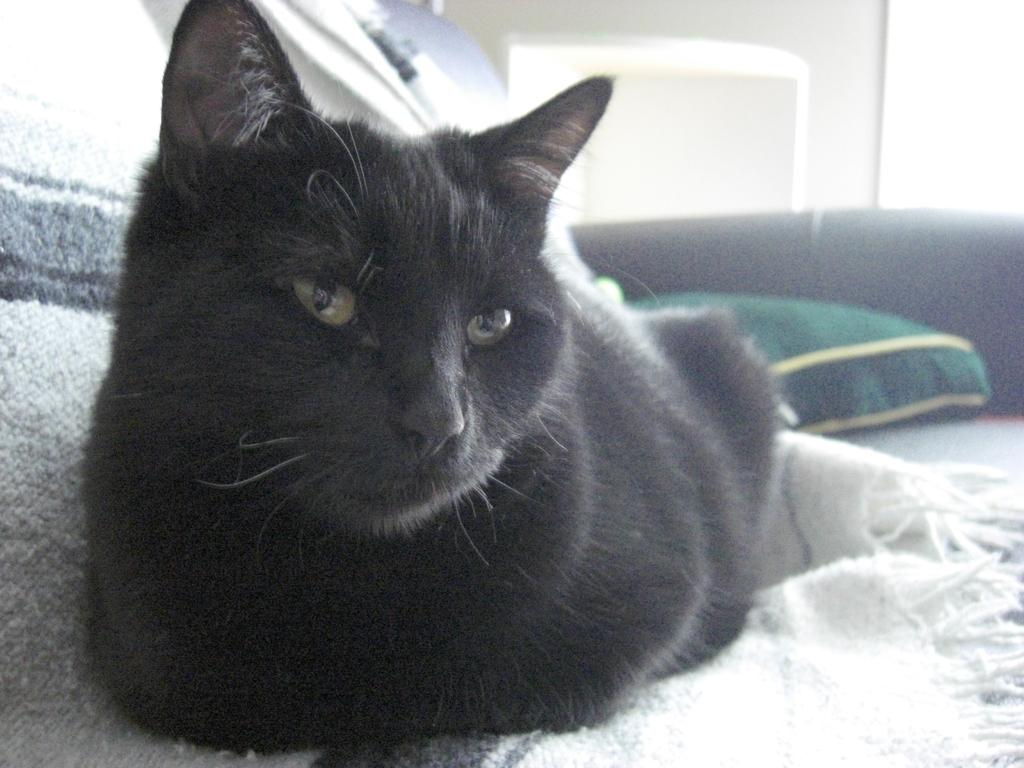What type of animal is in the image? There is a black cat in the image. What is the cat sitting on? The cat is on a cloth. What other object can be seen in the image? There is a pillow in the image. Is there any architectural feature visible in the image? Yes, there is a door in the image. What type of bubble is the cat playing with in the image? There is no bubble present in the image; it features a black cat on a cloth, a pillow, and a door. 